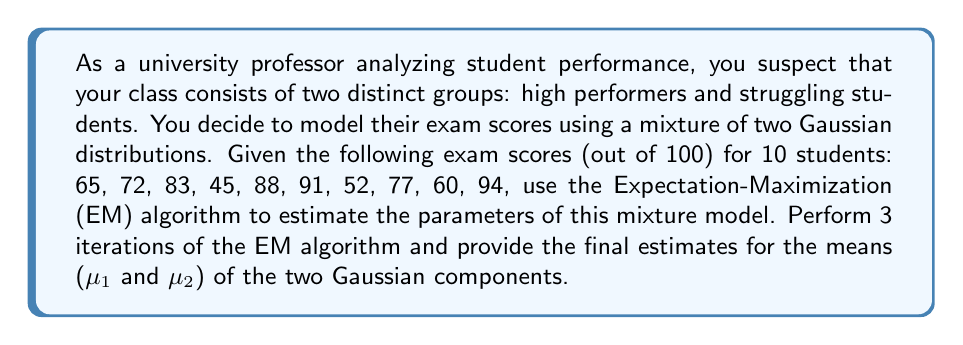Can you solve this math problem? Let's apply the EM algorithm to estimate the parameters of our mixture model:

1. Initialize parameters:
   Let's start with initial guesses:
   $\mu_1 = 60$, $\mu_2 = 80$, $\sigma_1 = \sigma_2 = 10$, $\pi_1 = \pi_2 = 0.5$

2. E-step:
   Calculate the responsibility (posterior probability) of each component for each data point:

   $\gamma_{ik} = \frac{\pi_k \mathcal{N}(x_i|\mu_k,\sigma_k^2)}{\sum_{j=1}^2 \pi_j \mathcal{N}(x_i|\mu_j,\sigma_j^2)}$

   Where $\mathcal{N}(x|\mu,\sigma^2)$ is the Gaussian probability density function.

3. M-step:
   Update the parameters:

   $\mu_k^{new} = \frac{\sum_{i=1}^N \gamma_{ik} x_i}{\sum_{i=1}^N \gamma_{ik}}$

   $\sigma_k^{2,new} = \frac{\sum_{i=1}^N \gamma_{ik} (x_i - \mu_k^{new})^2}{\sum_{i=1}^N \gamma_{ik}}$

   $\pi_k^{new} = \frac{1}{N}\sum_{i=1}^N \gamma_{ik}$

4. Repeat steps 2 and 3 for 3 iterations.

Iteration 1:
E-step: Calculate responsibilities (omitted for brevity)
M-step:
$\mu_1 = 58.95$, $\mu_2 = 84.13$
$\sigma_1 = 9.78$, $\sigma_2 = 7.14$
$\pi_1 = 0.47$, $\pi_2 = 0.53$

Iteration 2:
E-step: Recalculate responsibilities
M-step:
$\mu_1 = 57.89$, $\mu_2 = 85.02$
$\sigma_1 = 8.91$, $\sigma_2 = 6.39$
$\pi_1 = 0.46$, $\pi_2 = 0.54$

Iteration 3:
E-step: Recalculate responsibilities
M-step:
$\mu_1 = 57.40$, $\mu_2 = 85.42$
$\sigma_1 = 8.45$, $\sigma_2 = 6.01$
$\pi_1 = 0.45$, $\pi_2 = 0.55$

After 3 iterations, our final estimates for the means are:
$\mu_1 = 57.40$ and $\mu_2 = 85.42$
Answer: $\mu_1 = 57.40$, $\mu_2 = 85.42$ 